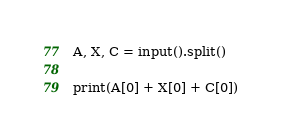<code> <loc_0><loc_0><loc_500><loc_500><_Python_>A, X, C = input().split()

print(A[0] + X[0] + C[0])</code> 